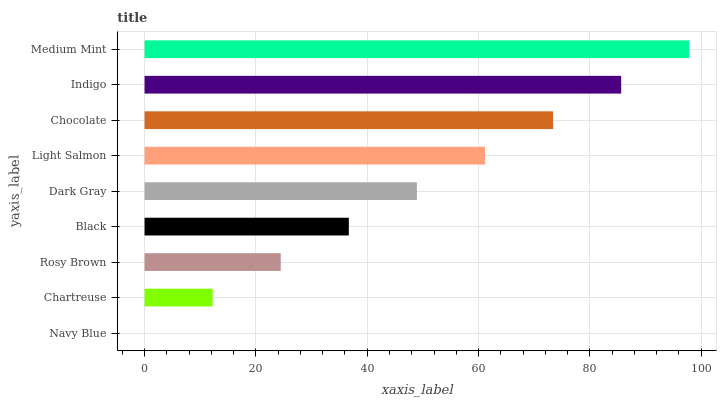Is Navy Blue the minimum?
Answer yes or no. Yes. Is Medium Mint the maximum?
Answer yes or no. Yes. Is Chartreuse the minimum?
Answer yes or no. No. Is Chartreuse the maximum?
Answer yes or no. No. Is Chartreuse greater than Navy Blue?
Answer yes or no. Yes. Is Navy Blue less than Chartreuse?
Answer yes or no. Yes. Is Navy Blue greater than Chartreuse?
Answer yes or no. No. Is Chartreuse less than Navy Blue?
Answer yes or no. No. Is Dark Gray the high median?
Answer yes or no. Yes. Is Dark Gray the low median?
Answer yes or no. Yes. Is Light Salmon the high median?
Answer yes or no. No. Is Chocolate the low median?
Answer yes or no. No. 